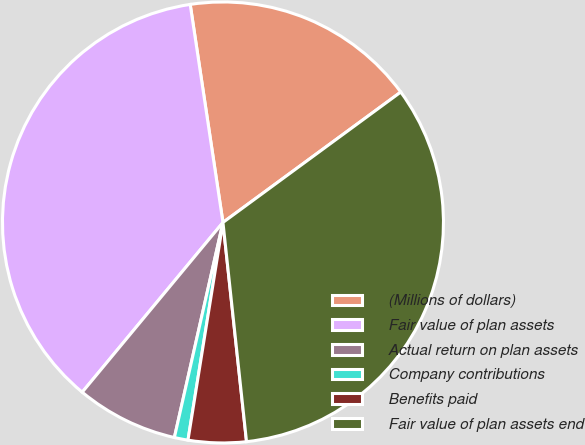<chart> <loc_0><loc_0><loc_500><loc_500><pie_chart><fcel>(Millions of dollars)<fcel>Fair value of plan assets<fcel>Actual return on plan assets<fcel>Company contributions<fcel>Benefits paid<fcel>Fair value of plan assets end<nl><fcel>17.3%<fcel>36.6%<fcel>7.48%<fcel>1.0%<fcel>4.24%<fcel>33.36%<nl></chart> 